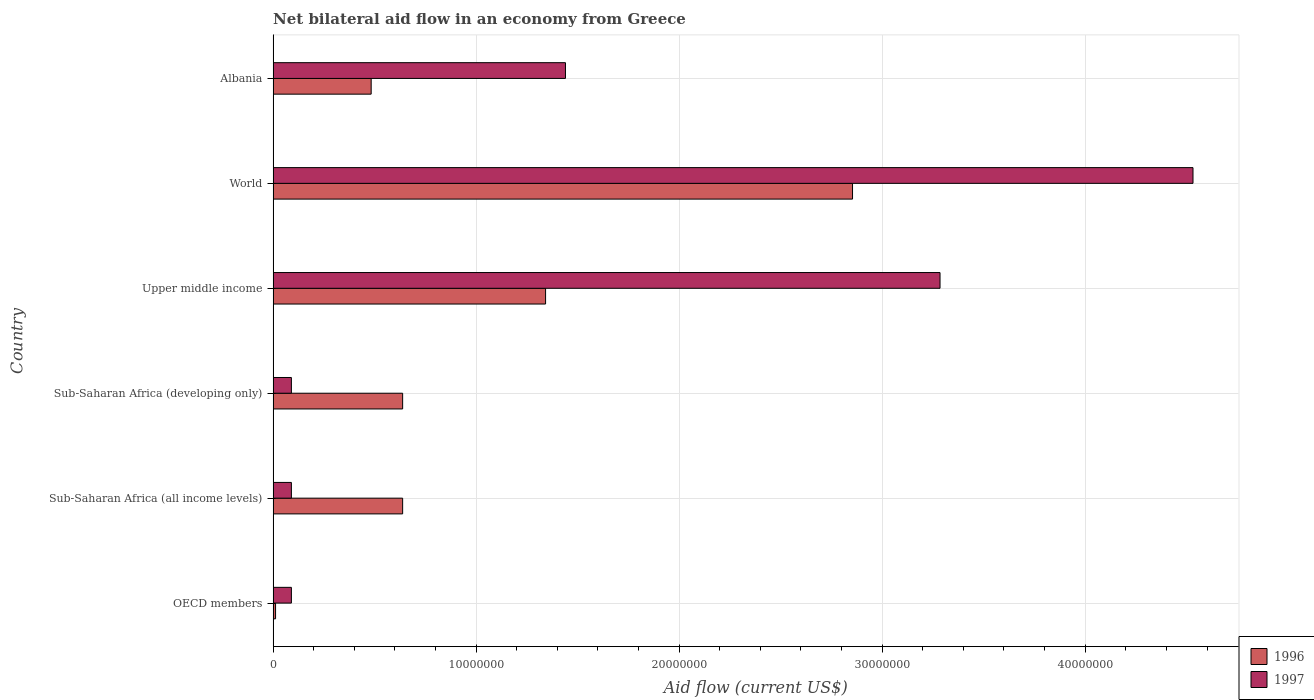Are the number of bars on each tick of the Y-axis equal?
Keep it short and to the point. Yes. How many bars are there on the 4th tick from the bottom?
Provide a succinct answer. 2. What is the label of the 1st group of bars from the top?
Your answer should be compact. Albania. In how many cases, is the number of bars for a given country not equal to the number of legend labels?
Provide a succinct answer. 0. What is the net bilateral aid flow in 1996 in Sub-Saharan Africa (developing only)?
Offer a very short reply. 6.38e+06. Across all countries, what is the maximum net bilateral aid flow in 1997?
Offer a very short reply. 4.53e+07. In which country was the net bilateral aid flow in 1997 maximum?
Your answer should be very brief. World. In which country was the net bilateral aid flow in 1997 minimum?
Offer a terse response. OECD members. What is the total net bilateral aid flow in 1997 in the graph?
Your response must be concise. 9.53e+07. What is the difference between the net bilateral aid flow in 1997 in Albania and that in Sub-Saharan Africa (all income levels)?
Offer a very short reply. 1.35e+07. What is the difference between the net bilateral aid flow in 1997 in OECD members and the net bilateral aid flow in 1996 in World?
Your answer should be very brief. -2.76e+07. What is the average net bilateral aid flow in 1997 per country?
Provide a short and direct response. 1.59e+07. What is the difference between the net bilateral aid flow in 1996 and net bilateral aid flow in 1997 in Albania?
Give a very brief answer. -9.57e+06. What is the ratio of the net bilateral aid flow in 1996 in OECD members to that in Upper middle income?
Provide a succinct answer. 0.01. Is the net bilateral aid flow in 1997 in Sub-Saharan Africa (developing only) less than that in World?
Offer a very short reply. Yes. Is the difference between the net bilateral aid flow in 1996 in OECD members and World greater than the difference between the net bilateral aid flow in 1997 in OECD members and World?
Make the answer very short. Yes. What is the difference between the highest and the second highest net bilateral aid flow in 1996?
Offer a very short reply. 1.51e+07. What is the difference between the highest and the lowest net bilateral aid flow in 1996?
Your answer should be compact. 2.84e+07. In how many countries, is the net bilateral aid flow in 1996 greater than the average net bilateral aid flow in 1996 taken over all countries?
Offer a terse response. 2. Is the sum of the net bilateral aid flow in 1997 in Albania and Upper middle income greater than the maximum net bilateral aid flow in 1996 across all countries?
Offer a terse response. Yes. What does the 1st bar from the bottom in World represents?
Offer a very short reply. 1996. Are all the bars in the graph horizontal?
Your answer should be compact. Yes. How many countries are there in the graph?
Your response must be concise. 6. Are the values on the major ticks of X-axis written in scientific E-notation?
Your answer should be very brief. No. Where does the legend appear in the graph?
Your answer should be very brief. Bottom right. How are the legend labels stacked?
Make the answer very short. Vertical. What is the title of the graph?
Provide a short and direct response. Net bilateral aid flow in an economy from Greece. Does "2004" appear as one of the legend labels in the graph?
Your answer should be compact. No. What is the label or title of the Y-axis?
Give a very brief answer. Country. What is the Aid flow (current US$) in 1996 in OECD members?
Ensure brevity in your answer.  1.20e+05. What is the Aid flow (current US$) of 1996 in Sub-Saharan Africa (all income levels)?
Keep it short and to the point. 6.38e+06. What is the Aid flow (current US$) of 1997 in Sub-Saharan Africa (all income levels)?
Offer a terse response. 9.00e+05. What is the Aid flow (current US$) of 1996 in Sub-Saharan Africa (developing only)?
Your answer should be very brief. 6.38e+06. What is the Aid flow (current US$) in 1996 in Upper middle income?
Make the answer very short. 1.34e+07. What is the Aid flow (current US$) of 1997 in Upper middle income?
Provide a succinct answer. 3.28e+07. What is the Aid flow (current US$) in 1996 in World?
Provide a short and direct response. 2.85e+07. What is the Aid flow (current US$) in 1997 in World?
Keep it short and to the point. 4.53e+07. What is the Aid flow (current US$) in 1996 in Albania?
Offer a terse response. 4.83e+06. What is the Aid flow (current US$) in 1997 in Albania?
Ensure brevity in your answer.  1.44e+07. Across all countries, what is the maximum Aid flow (current US$) in 1996?
Your answer should be very brief. 2.85e+07. Across all countries, what is the maximum Aid flow (current US$) in 1997?
Make the answer very short. 4.53e+07. Across all countries, what is the minimum Aid flow (current US$) in 1996?
Offer a terse response. 1.20e+05. Across all countries, what is the minimum Aid flow (current US$) of 1997?
Your answer should be compact. 9.00e+05. What is the total Aid flow (current US$) of 1996 in the graph?
Ensure brevity in your answer.  5.97e+07. What is the total Aid flow (current US$) of 1997 in the graph?
Offer a very short reply. 9.53e+07. What is the difference between the Aid flow (current US$) of 1996 in OECD members and that in Sub-Saharan Africa (all income levels)?
Provide a short and direct response. -6.26e+06. What is the difference between the Aid flow (current US$) of 1996 in OECD members and that in Sub-Saharan Africa (developing only)?
Offer a terse response. -6.26e+06. What is the difference between the Aid flow (current US$) in 1996 in OECD members and that in Upper middle income?
Give a very brief answer. -1.33e+07. What is the difference between the Aid flow (current US$) in 1997 in OECD members and that in Upper middle income?
Your response must be concise. -3.20e+07. What is the difference between the Aid flow (current US$) in 1996 in OECD members and that in World?
Ensure brevity in your answer.  -2.84e+07. What is the difference between the Aid flow (current US$) of 1997 in OECD members and that in World?
Offer a very short reply. -4.44e+07. What is the difference between the Aid flow (current US$) of 1996 in OECD members and that in Albania?
Your answer should be compact. -4.71e+06. What is the difference between the Aid flow (current US$) of 1997 in OECD members and that in Albania?
Offer a very short reply. -1.35e+07. What is the difference between the Aid flow (current US$) in 1997 in Sub-Saharan Africa (all income levels) and that in Sub-Saharan Africa (developing only)?
Your response must be concise. 0. What is the difference between the Aid flow (current US$) of 1996 in Sub-Saharan Africa (all income levels) and that in Upper middle income?
Your answer should be very brief. -7.04e+06. What is the difference between the Aid flow (current US$) of 1997 in Sub-Saharan Africa (all income levels) and that in Upper middle income?
Offer a terse response. -3.20e+07. What is the difference between the Aid flow (current US$) of 1996 in Sub-Saharan Africa (all income levels) and that in World?
Make the answer very short. -2.22e+07. What is the difference between the Aid flow (current US$) in 1997 in Sub-Saharan Africa (all income levels) and that in World?
Your answer should be very brief. -4.44e+07. What is the difference between the Aid flow (current US$) of 1996 in Sub-Saharan Africa (all income levels) and that in Albania?
Provide a succinct answer. 1.55e+06. What is the difference between the Aid flow (current US$) in 1997 in Sub-Saharan Africa (all income levels) and that in Albania?
Your response must be concise. -1.35e+07. What is the difference between the Aid flow (current US$) of 1996 in Sub-Saharan Africa (developing only) and that in Upper middle income?
Provide a short and direct response. -7.04e+06. What is the difference between the Aid flow (current US$) of 1997 in Sub-Saharan Africa (developing only) and that in Upper middle income?
Offer a terse response. -3.20e+07. What is the difference between the Aid flow (current US$) of 1996 in Sub-Saharan Africa (developing only) and that in World?
Ensure brevity in your answer.  -2.22e+07. What is the difference between the Aid flow (current US$) in 1997 in Sub-Saharan Africa (developing only) and that in World?
Ensure brevity in your answer.  -4.44e+07. What is the difference between the Aid flow (current US$) in 1996 in Sub-Saharan Africa (developing only) and that in Albania?
Your response must be concise. 1.55e+06. What is the difference between the Aid flow (current US$) of 1997 in Sub-Saharan Africa (developing only) and that in Albania?
Offer a very short reply. -1.35e+07. What is the difference between the Aid flow (current US$) of 1996 in Upper middle income and that in World?
Offer a terse response. -1.51e+07. What is the difference between the Aid flow (current US$) of 1997 in Upper middle income and that in World?
Keep it short and to the point. -1.25e+07. What is the difference between the Aid flow (current US$) in 1996 in Upper middle income and that in Albania?
Offer a very short reply. 8.59e+06. What is the difference between the Aid flow (current US$) in 1997 in Upper middle income and that in Albania?
Provide a short and direct response. 1.84e+07. What is the difference between the Aid flow (current US$) in 1996 in World and that in Albania?
Keep it short and to the point. 2.37e+07. What is the difference between the Aid flow (current US$) in 1997 in World and that in Albania?
Give a very brief answer. 3.09e+07. What is the difference between the Aid flow (current US$) in 1996 in OECD members and the Aid flow (current US$) in 1997 in Sub-Saharan Africa (all income levels)?
Your response must be concise. -7.80e+05. What is the difference between the Aid flow (current US$) of 1996 in OECD members and the Aid flow (current US$) of 1997 in Sub-Saharan Africa (developing only)?
Provide a succinct answer. -7.80e+05. What is the difference between the Aid flow (current US$) of 1996 in OECD members and the Aid flow (current US$) of 1997 in Upper middle income?
Your response must be concise. -3.27e+07. What is the difference between the Aid flow (current US$) of 1996 in OECD members and the Aid flow (current US$) of 1997 in World?
Ensure brevity in your answer.  -4.52e+07. What is the difference between the Aid flow (current US$) in 1996 in OECD members and the Aid flow (current US$) in 1997 in Albania?
Your answer should be compact. -1.43e+07. What is the difference between the Aid flow (current US$) in 1996 in Sub-Saharan Africa (all income levels) and the Aid flow (current US$) in 1997 in Sub-Saharan Africa (developing only)?
Your response must be concise. 5.48e+06. What is the difference between the Aid flow (current US$) in 1996 in Sub-Saharan Africa (all income levels) and the Aid flow (current US$) in 1997 in Upper middle income?
Provide a succinct answer. -2.65e+07. What is the difference between the Aid flow (current US$) of 1996 in Sub-Saharan Africa (all income levels) and the Aid flow (current US$) of 1997 in World?
Make the answer very short. -3.89e+07. What is the difference between the Aid flow (current US$) in 1996 in Sub-Saharan Africa (all income levels) and the Aid flow (current US$) in 1997 in Albania?
Provide a short and direct response. -8.02e+06. What is the difference between the Aid flow (current US$) in 1996 in Sub-Saharan Africa (developing only) and the Aid flow (current US$) in 1997 in Upper middle income?
Your answer should be very brief. -2.65e+07. What is the difference between the Aid flow (current US$) of 1996 in Sub-Saharan Africa (developing only) and the Aid flow (current US$) of 1997 in World?
Give a very brief answer. -3.89e+07. What is the difference between the Aid flow (current US$) of 1996 in Sub-Saharan Africa (developing only) and the Aid flow (current US$) of 1997 in Albania?
Give a very brief answer. -8.02e+06. What is the difference between the Aid flow (current US$) in 1996 in Upper middle income and the Aid flow (current US$) in 1997 in World?
Your answer should be compact. -3.19e+07. What is the difference between the Aid flow (current US$) of 1996 in Upper middle income and the Aid flow (current US$) of 1997 in Albania?
Make the answer very short. -9.80e+05. What is the difference between the Aid flow (current US$) in 1996 in World and the Aid flow (current US$) in 1997 in Albania?
Provide a succinct answer. 1.41e+07. What is the average Aid flow (current US$) of 1996 per country?
Give a very brief answer. 9.94e+06. What is the average Aid flow (current US$) of 1997 per country?
Make the answer very short. 1.59e+07. What is the difference between the Aid flow (current US$) of 1996 and Aid flow (current US$) of 1997 in OECD members?
Give a very brief answer. -7.80e+05. What is the difference between the Aid flow (current US$) of 1996 and Aid flow (current US$) of 1997 in Sub-Saharan Africa (all income levels)?
Keep it short and to the point. 5.48e+06. What is the difference between the Aid flow (current US$) in 1996 and Aid flow (current US$) in 1997 in Sub-Saharan Africa (developing only)?
Your answer should be very brief. 5.48e+06. What is the difference between the Aid flow (current US$) in 1996 and Aid flow (current US$) in 1997 in Upper middle income?
Ensure brevity in your answer.  -1.94e+07. What is the difference between the Aid flow (current US$) in 1996 and Aid flow (current US$) in 1997 in World?
Keep it short and to the point. -1.68e+07. What is the difference between the Aid flow (current US$) in 1996 and Aid flow (current US$) in 1997 in Albania?
Make the answer very short. -9.57e+06. What is the ratio of the Aid flow (current US$) of 1996 in OECD members to that in Sub-Saharan Africa (all income levels)?
Make the answer very short. 0.02. What is the ratio of the Aid flow (current US$) in 1997 in OECD members to that in Sub-Saharan Africa (all income levels)?
Keep it short and to the point. 1. What is the ratio of the Aid flow (current US$) of 1996 in OECD members to that in Sub-Saharan Africa (developing only)?
Your response must be concise. 0.02. What is the ratio of the Aid flow (current US$) of 1997 in OECD members to that in Sub-Saharan Africa (developing only)?
Offer a very short reply. 1. What is the ratio of the Aid flow (current US$) of 1996 in OECD members to that in Upper middle income?
Your response must be concise. 0.01. What is the ratio of the Aid flow (current US$) of 1997 in OECD members to that in Upper middle income?
Keep it short and to the point. 0.03. What is the ratio of the Aid flow (current US$) in 1996 in OECD members to that in World?
Provide a succinct answer. 0. What is the ratio of the Aid flow (current US$) of 1997 in OECD members to that in World?
Provide a succinct answer. 0.02. What is the ratio of the Aid flow (current US$) in 1996 in OECD members to that in Albania?
Keep it short and to the point. 0.02. What is the ratio of the Aid flow (current US$) of 1997 in OECD members to that in Albania?
Your response must be concise. 0.06. What is the ratio of the Aid flow (current US$) in 1996 in Sub-Saharan Africa (all income levels) to that in Sub-Saharan Africa (developing only)?
Provide a short and direct response. 1. What is the ratio of the Aid flow (current US$) of 1996 in Sub-Saharan Africa (all income levels) to that in Upper middle income?
Keep it short and to the point. 0.48. What is the ratio of the Aid flow (current US$) in 1997 in Sub-Saharan Africa (all income levels) to that in Upper middle income?
Give a very brief answer. 0.03. What is the ratio of the Aid flow (current US$) in 1996 in Sub-Saharan Africa (all income levels) to that in World?
Offer a terse response. 0.22. What is the ratio of the Aid flow (current US$) of 1997 in Sub-Saharan Africa (all income levels) to that in World?
Offer a terse response. 0.02. What is the ratio of the Aid flow (current US$) in 1996 in Sub-Saharan Africa (all income levels) to that in Albania?
Your answer should be compact. 1.32. What is the ratio of the Aid flow (current US$) of 1997 in Sub-Saharan Africa (all income levels) to that in Albania?
Provide a short and direct response. 0.06. What is the ratio of the Aid flow (current US$) of 1996 in Sub-Saharan Africa (developing only) to that in Upper middle income?
Offer a terse response. 0.48. What is the ratio of the Aid flow (current US$) of 1997 in Sub-Saharan Africa (developing only) to that in Upper middle income?
Make the answer very short. 0.03. What is the ratio of the Aid flow (current US$) of 1996 in Sub-Saharan Africa (developing only) to that in World?
Ensure brevity in your answer.  0.22. What is the ratio of the Aid flow (current US$) in 1997 in Sub-Saharan Africa (developing only) to that in World?
Offer a terse response. 0.02. What is the ratio of the Aid flow (current US$) of 1996 in Sub-Saharan Africa (developing only) to that in Albania?
Your response must be concise. 1.32. What is the ratio of the Aid flow (current US$) in 1997 in Sub-Saharan Africa (developing only) to that in Albania?
Make the answer very short. 0.06. What is the ratio of the Aid flow (current US$) of 1996 in Upper middle income to that in World?
Your response must be concise. 0.47. What is the ratio of the Aid flow (current US$) of 1997 in Upper middle income to that in World?
Offer a terse response. 0.72. What is the ratio of the Aid flow (current US$) of 1996 in Upper middle income to that in Albania?
Make the answer very short. 2.78. What is the ratio of the Aid flow (current US$) of 1997 in Upper middle income to that in Albania?
Offer a very short reply. 2.28. What is the ratio of the Aid flow (current US$) in 1996 in World to that in Albania?
Your answer should be compact. 5.91. What is the ratio of the Aid flow (current US$) of 1997 in World to that in Albania?
Offer a terse response. 3.15. What is the difference between the highest and the second highest Aid flow (current US$) in 1996?
Provide a short and direct response. 1.51e+07. What is the difference between the highest and the second highest Aid flow (current US$) of 1997?
Your answer should be compact. 1.25e+07. What is the difference between the highest and the lowest Aid flow (current US$) in 1996?
Offer a terse response. 2.84e+07. What is the difference between the highest and the lowest Aid flow (current US$) in 1997?
Provide a succinct answer. 4.44e+07. 